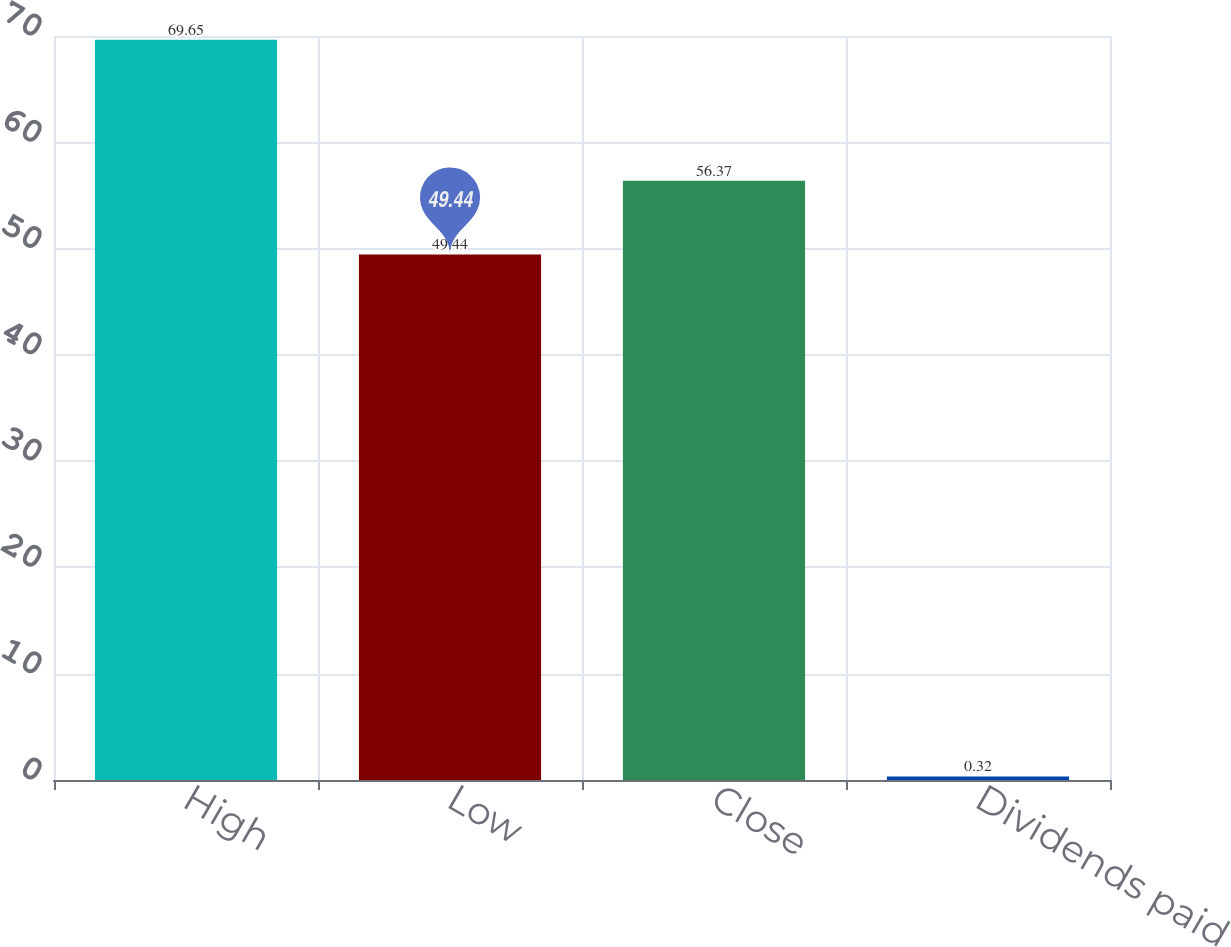Convert chart. <chart><loc_0><loc_0><loc_500><loc_500><bar_chart><fcel>High<fcel>Low<fcel>Close<fcel>Dividends paid<nl><fcel>69.65<fcel>49.44<fcel>56.37<fcel>0.32<nl></chart> 